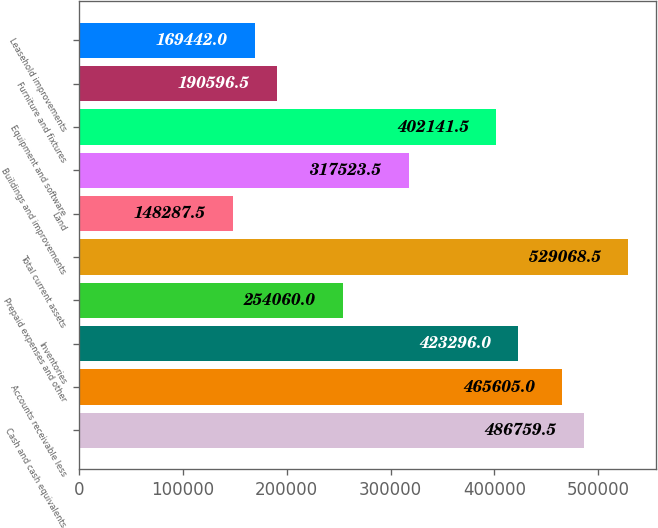<chart> <loc_0><loc_0><loc_500><loc_500><bar_chart><fcel>Cash and cash equivalents<fcel>Accounts receivable less<fcel>Inventories<fcel>Prepaid expenses and other<fcel>Total current assets<fcel>Land<fcel>Buildings and improvements<fcel>Equipment and software<fcel>Furniture and fixtures<fcel>Leasehold improvements<nl><fcel>486760<fcel>465605<fcel>423296<fcel>254060<fcel>529068<fcel>148288<fcel>317524<fcel>402142<fcel>190596<fcel>169442<nl></chart> 